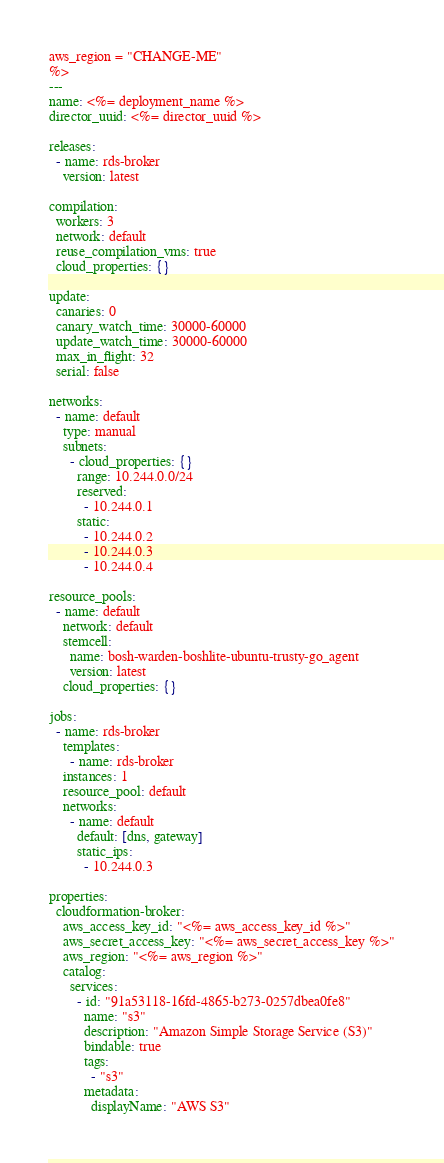<code> <loc_0><loc_0><loc_500><loc_500><_YAML_>aws_region = "CHANGE-ME"
%>
---
name: <%= deployment_name %>
director_uuid: <%= director_uuid %>

releases:
  - name: rds-broker
    version: latest

compilation:
  workers: 3
  network: default
  reuse_compilation_vms: true
  cloud_properties: {}

update:
  canaries: 0
  canary_watch_time: 30000-60000
  update_watch_time: 30000-60000
  max_in_flight: 32
  serial: false

networks:
  - name: default
    type: manual
    subnets:
      - cloud_properties: {}
        range: 10.244.0.0/24
        reserved:
          - 10.244.0.1
        static:
          - 10.244.0.2
          - 10.244.0.3
          - 10.244.0.4

resource_pools:
  - name: default
    network: default
    stemcell:
      name: bosh-warden-boshlite-ubuntu-trusty-go_agent
      version: latest
    cloud_properties: {}

jobs:
  - name: rds-broker
    templates:
      - name: rds-broker
    instances: 1
    resource_pool: default
    networks:
      - name: default
        default: [dns, gateway]
        static_ips:
          - 10.244.0.3

properties:
  cloudformation-broker:
    aws_access_key_id: "<%= aws_access_key_id %>"
    aws_secret_access_key: "<%= aws_secret_access_key %>"
    aws_region: "<%= aws_region %>"
    catalog:
      services:
        - id: "91a53118-16fd-4865-b273-0257dbea0fe8"
          name: "s3"
          description: "Amazon Simple Storage Service (S3)"
          bindable: true
          tags:
            - "s3"
          metadata:
            displayName: "AWS S3"</code> 